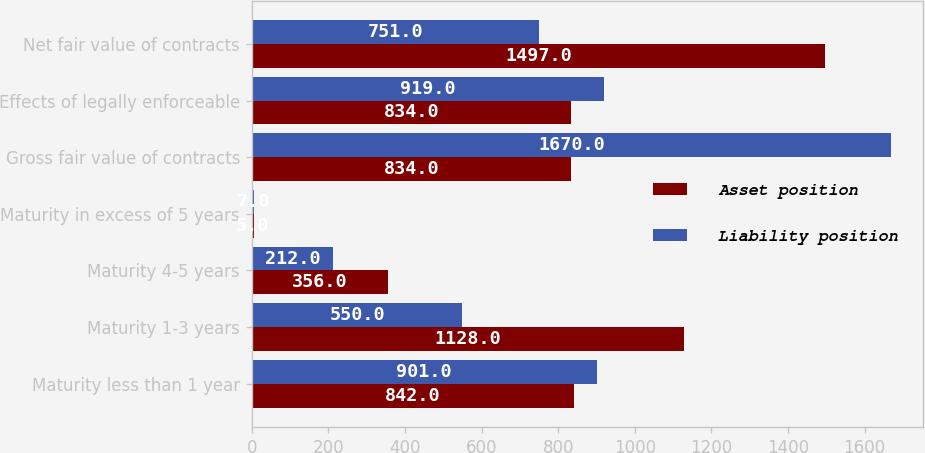Convert chart to OTSL. <chart><loc_0><loc_0><loc_500><loc_500><stacked_bar_chart><ecel><fcel>Maturity less than 1 year<fcel>Maturity 1-3 years<fcel>Maturity 4-5 years<fcel>Maturity in excess of 5 years<fcel>Gross fair value of contracts<fcel>Effects of legally enforceable<fcel>Net fair value of contracts<nl><fcel>Asset position<fcel>842<fcel>1128<fcel>356<fcel>5<fcel>834<fcel>834<fcel>1497<nl><fcel>Liability position<fcel>901<fcel>550<fcel>212<fcel>7<fcel>1670<fcel>919<fcel>751<nl></chart> 